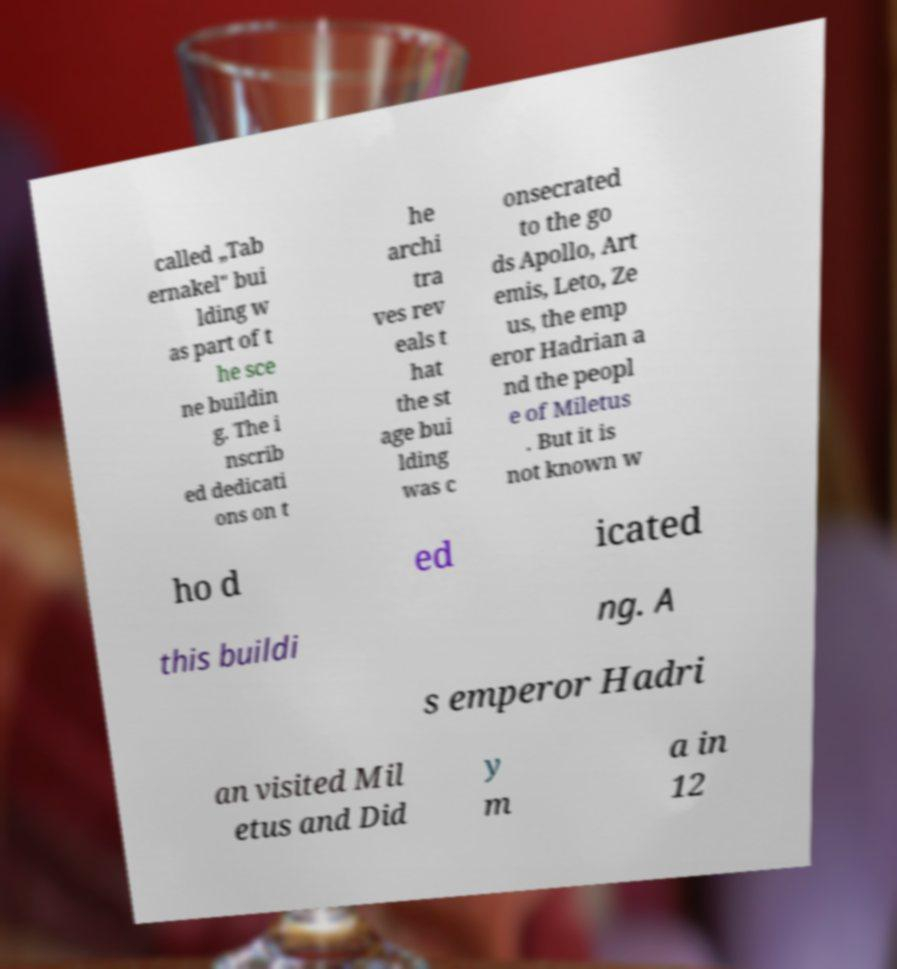Can you read and provide the text displayed in the image?This photo seems to have some interesting text. Can you extract and type it out for me? called „Tab ernakel" bui lding w as part of t he sce ne buildin g. The i nscrib ed dedicati ons on t he archi tra ves rev eals t hat the st age bui lding was c onsecrated to the go ds Apollo, Art emis, Leto, Ze us, the emp eror Hadrian a nd the peopl e of Miletus . But it is not known w ho d ed icated this buildi ng. A s emperor Hadri an visited Mil etus and Did y m a in 12 